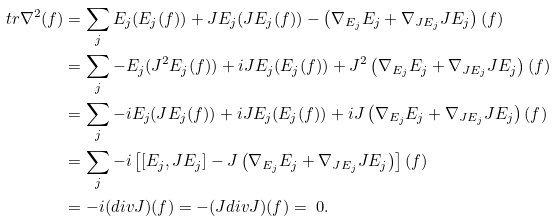Convert formula to latex. <formula><loc_0><loc_0><loc_500><loc_500>\ t r \nabla ^ { 2 } ( f ) & = \sum _ { j } E _ { j } ( E _ { j } ( f ) ) + J E _ { j } ( J E _ { j } ( f ) ) - \left ( \nabla _ { E _ { j } } E _ { j } + \nabla _ { J E _ { j } } J E _ { j } \right ) ( f ) \\ & = \sum _ { j } - E _ { j } ( J ^ { 2 } E _ { j } ( f ) ) + i J E _ { j } ( E _ { j } ( f ) ) + J ^ { 2 } \left ( \nabla _ { E _ { j } } E _ { j } + \nabla _ { J E _ { j } } J E _ { j } \right ) ( f ) \\ & = \sum _ { j } - i E _ { j } ( J E _ { j } ( f ) ) + i J E _ { j } ( E _ { j } ( f ) ) + i J \left ( \nabla _ { E _ { j } } E _ { j } + \nabla _ { J E _ { j } } J E _ { j } \right ) ( f ) \\ & = \sum _ { j } - i \left [ [ E _ { j } , J E _ { j } ] - J \left ( \nabla _ { E _ { j } } E _ { j } + \nabla _ { J E _ { j } } J E _ { j } \right ) \right ] ( f ) \\ & = - i ( d i v J ) ( f ) = - ( J d i v J ) ( f ) = \ 0 .</formula> 